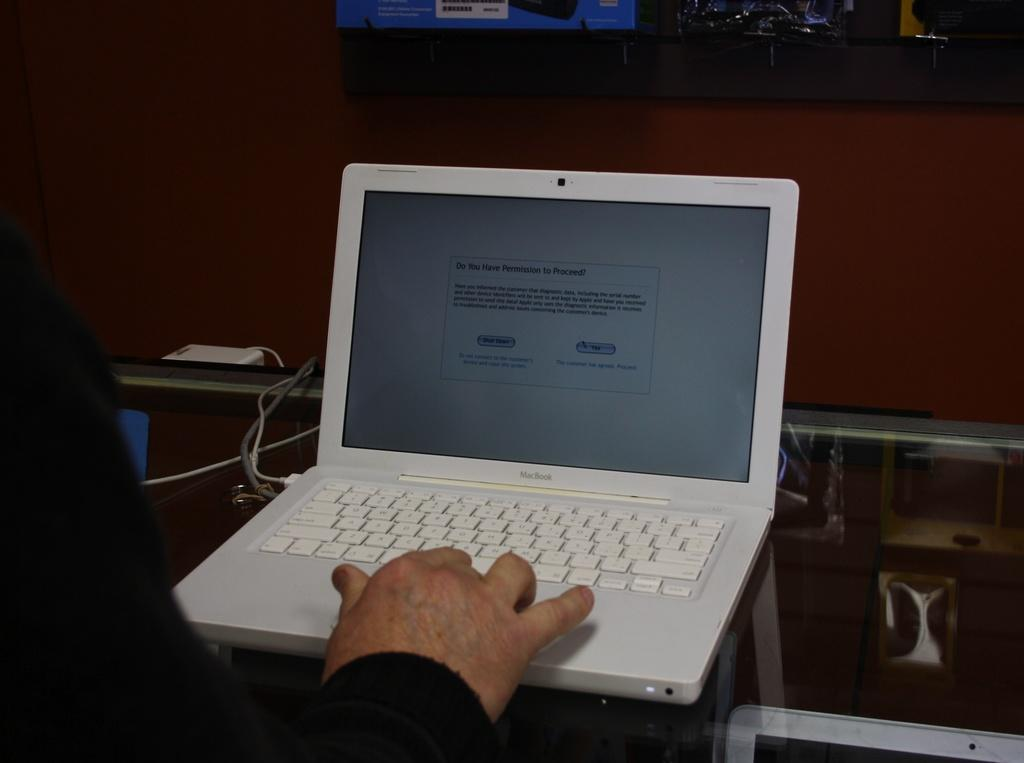<image>
Share a concise interpretation of the image provided. The computer is offering two options, shut down or yes 